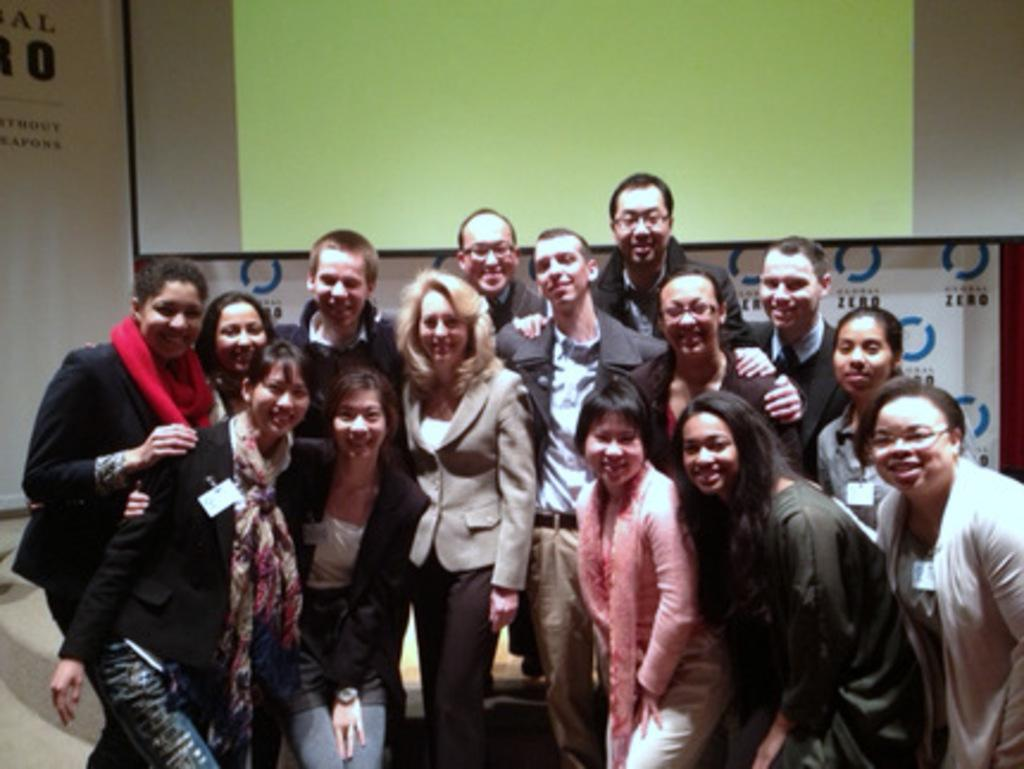Who or what is present in the image? There are people in the image. What are the people doing or expressing? The people are smiling. What can be seen in the background of the image? There is a screen and banners visible in the background. How much money is being exchanged between the people in the image? There is no indication of money exchange in the image; the people are simply smiling. 